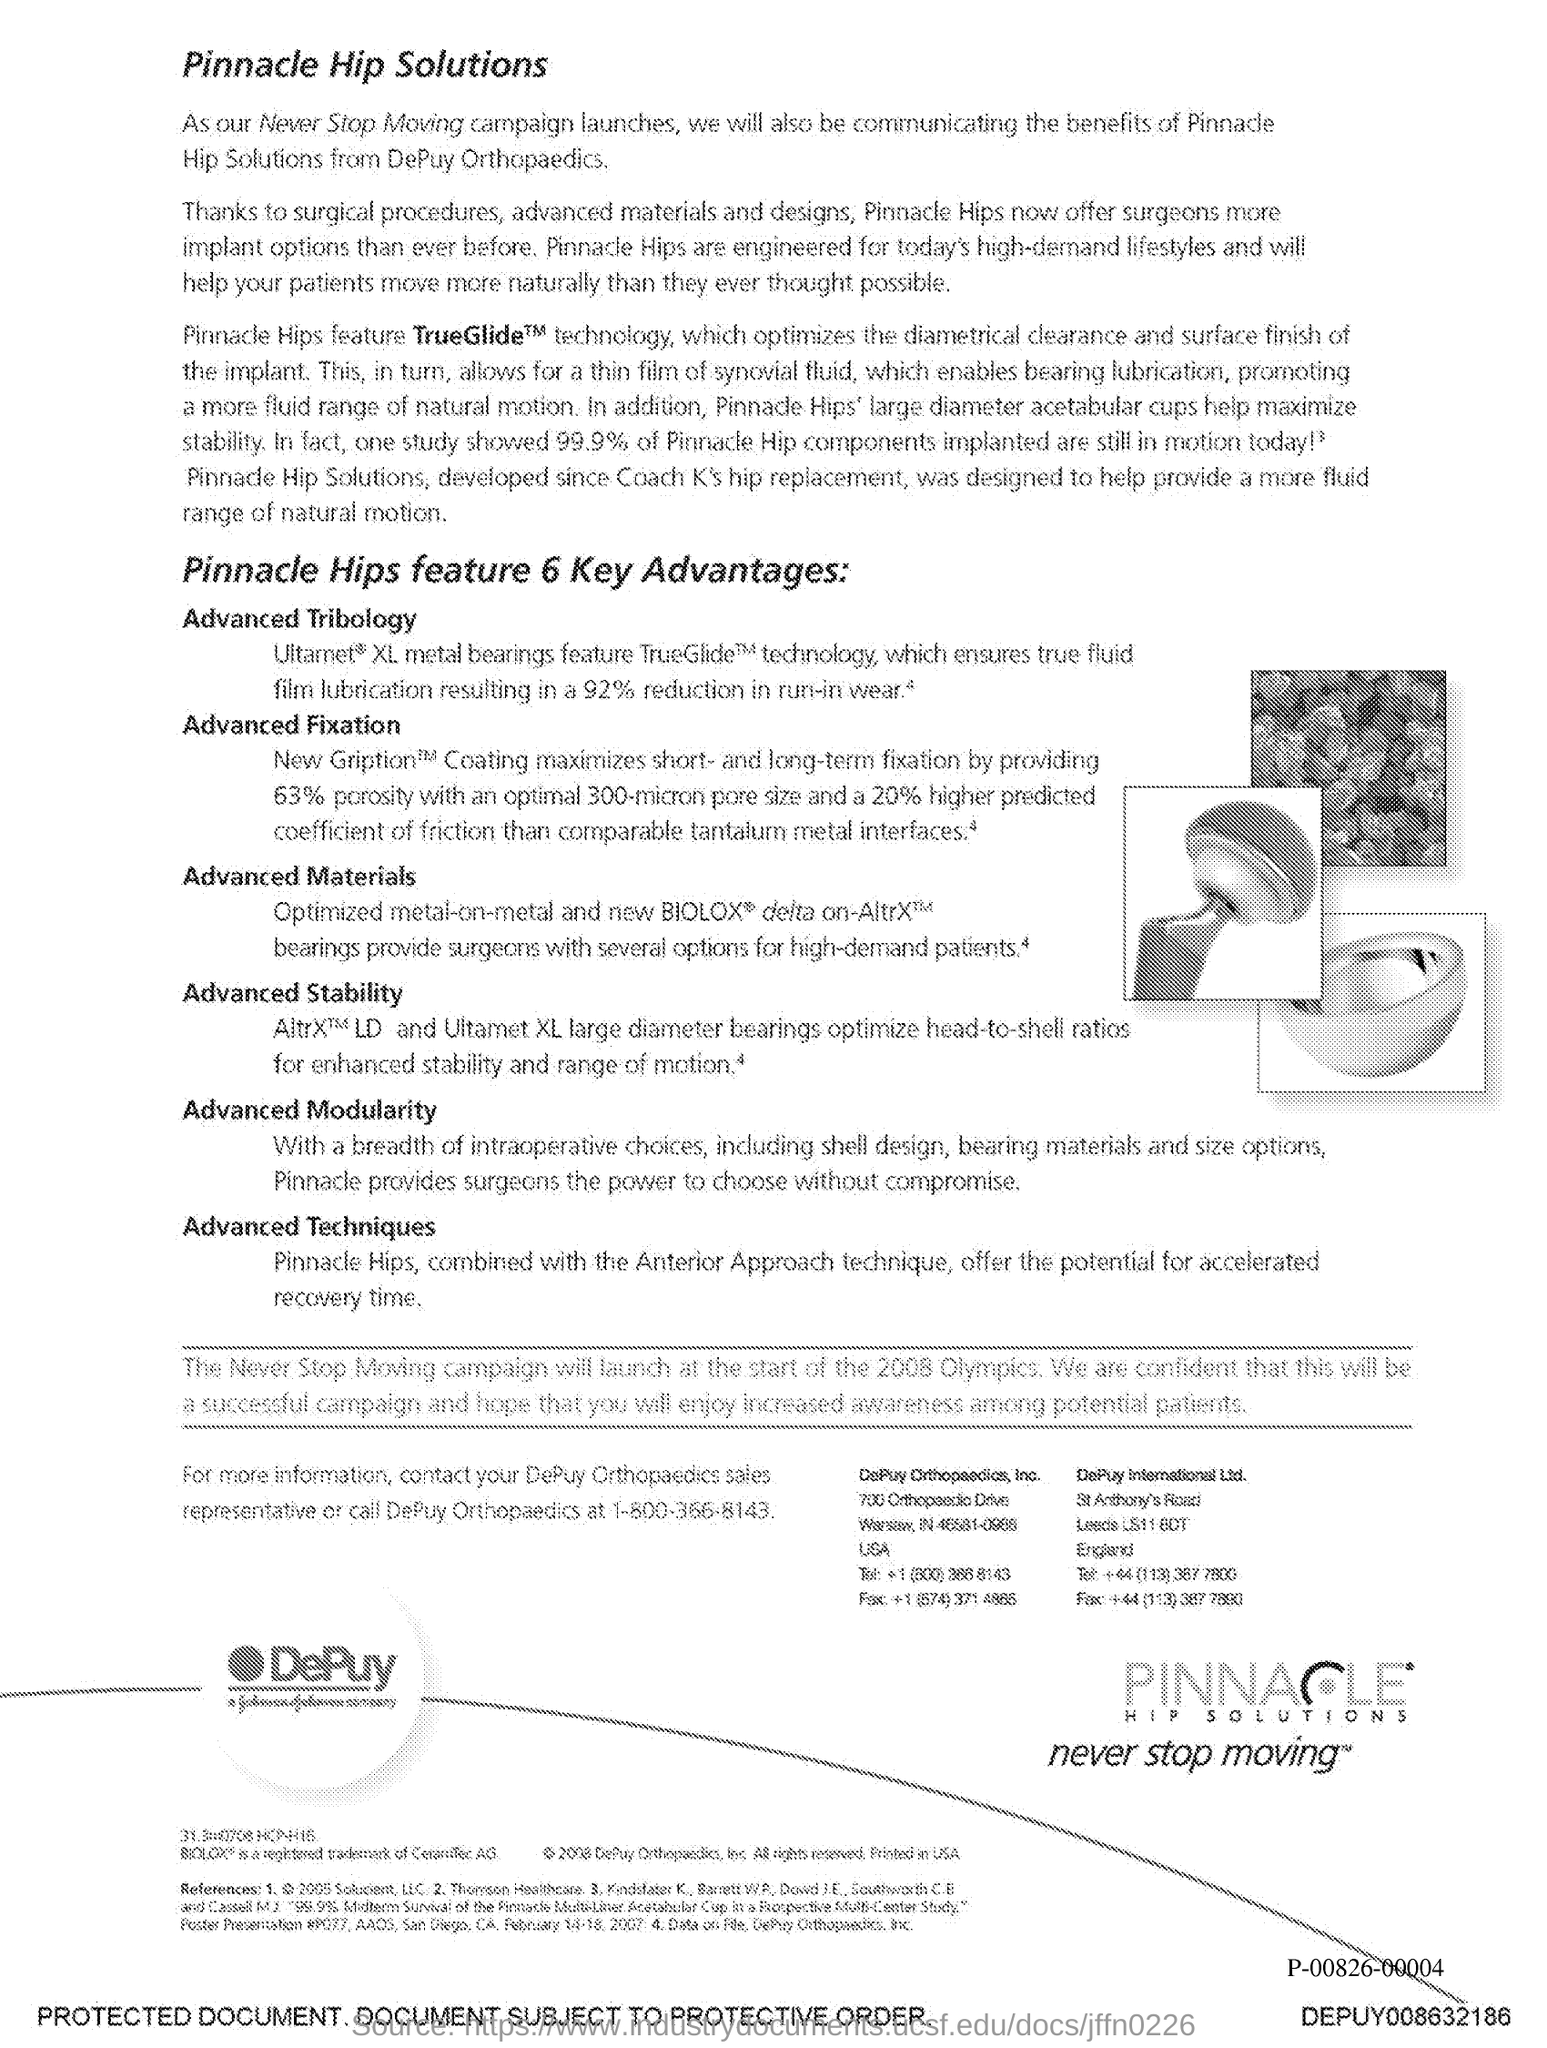Identify some key points in this picture. The first title in the document is "Pinnacle Hip Solutions. 